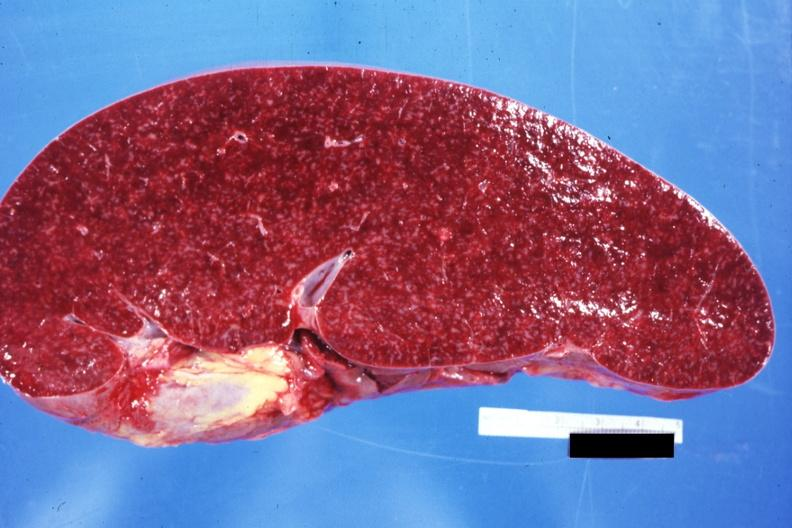what is present?
Answer the question using a single word or phrase. Hematologic 